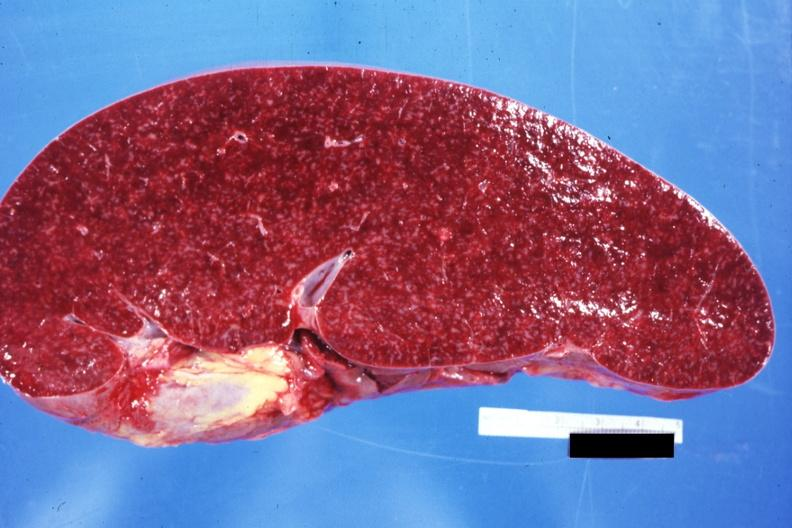what is present?
Answer the question using a single word or phrase. Hematologic 